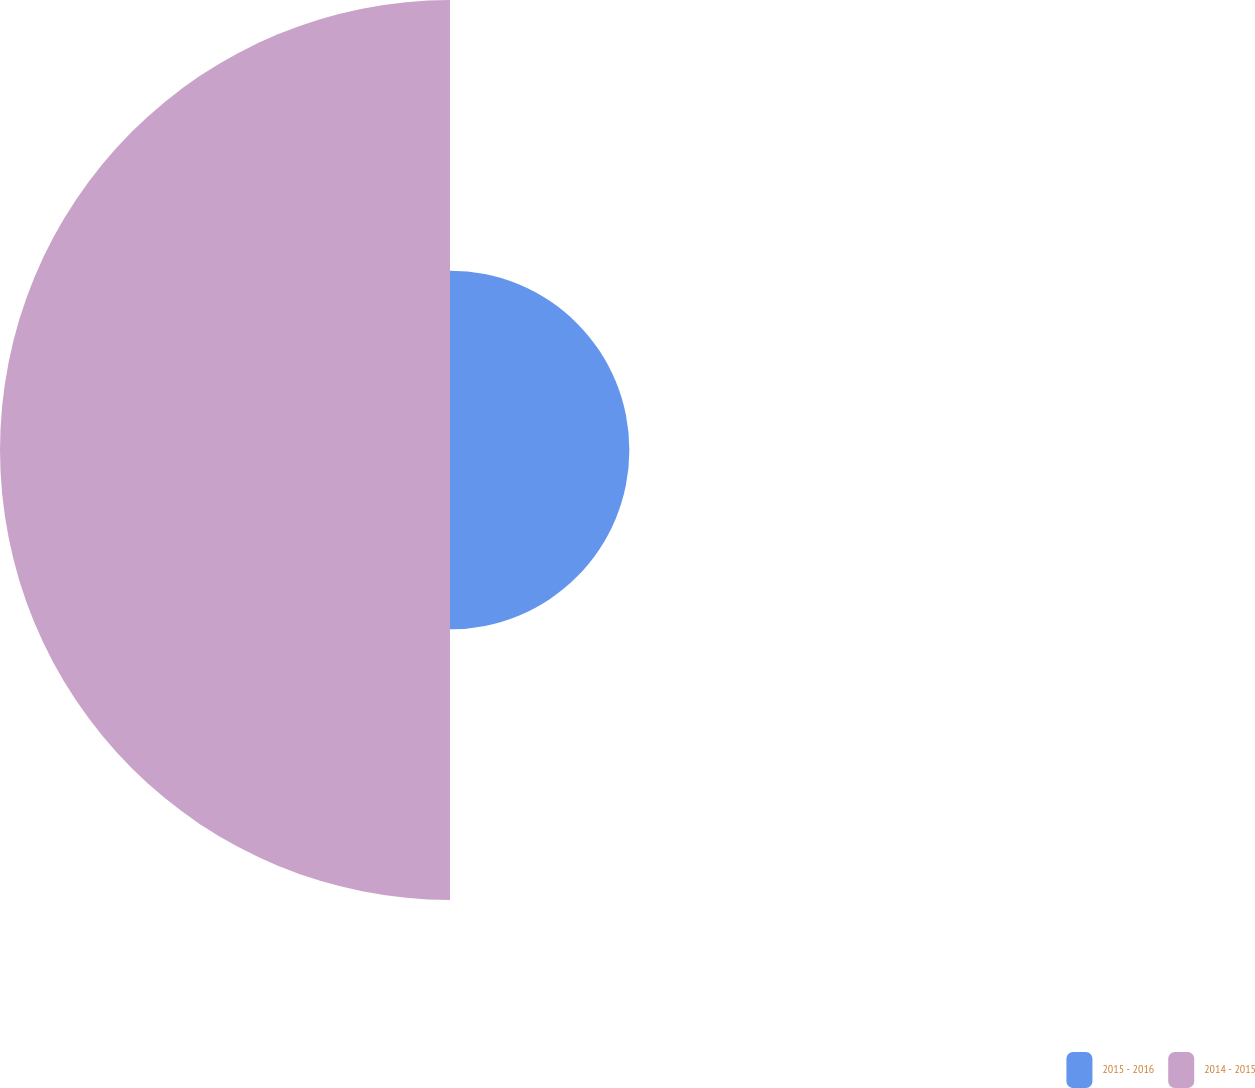<chart> <loc_0><loc_0><loc_500><loc_500><pie_chart><fcel>2015 - 2016<fcel>2014 - 2015<nl><fcel>28.5%<fcel>71.5%<nl></chart> 